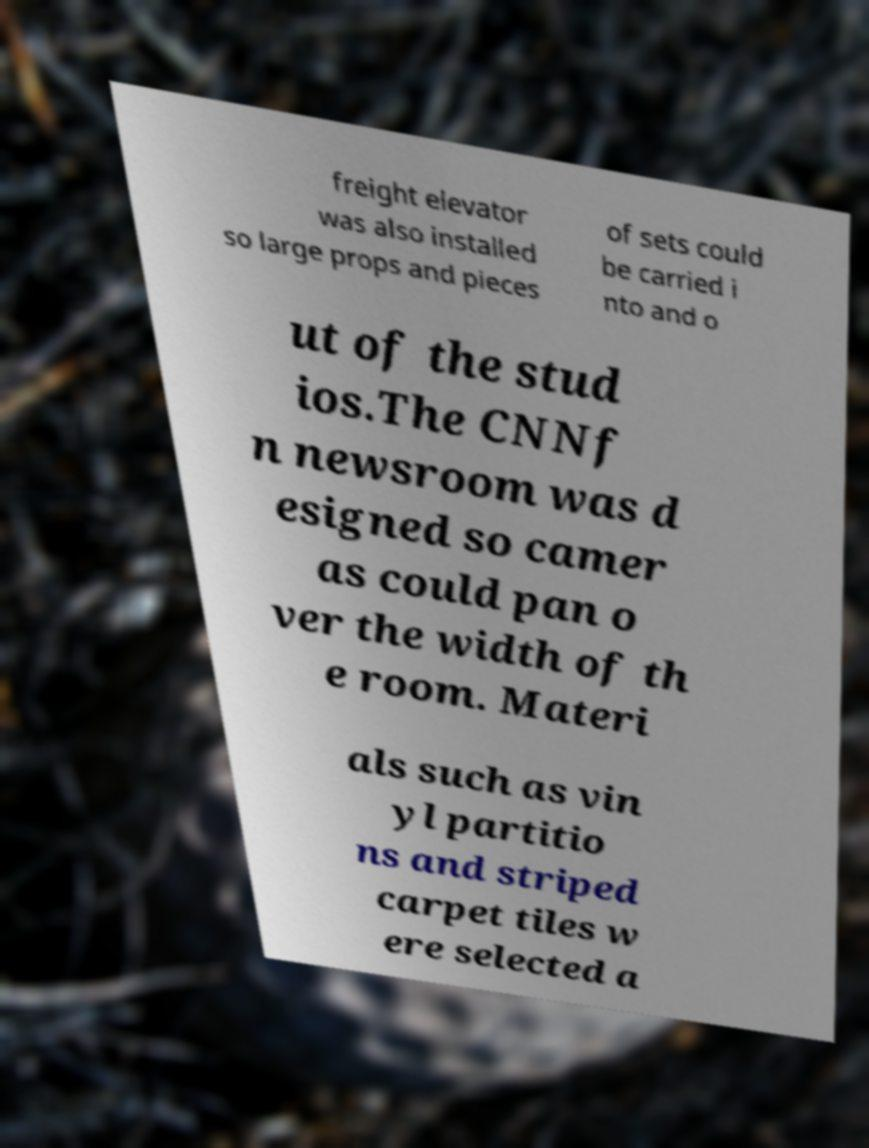Can you read and provide the text displayed in the image?This photo seems to have some interesting text. Can you extract and type it out for me? freight elevator was also installed so large props and pieces of sets could be carried i nto and o ut of the stud ios.The CNNf n newsroom was d esigned so camer as could pan o ver the width of th e room. Materi als such as vin yl partitio ns and striped carpet tiles w ere selected a 